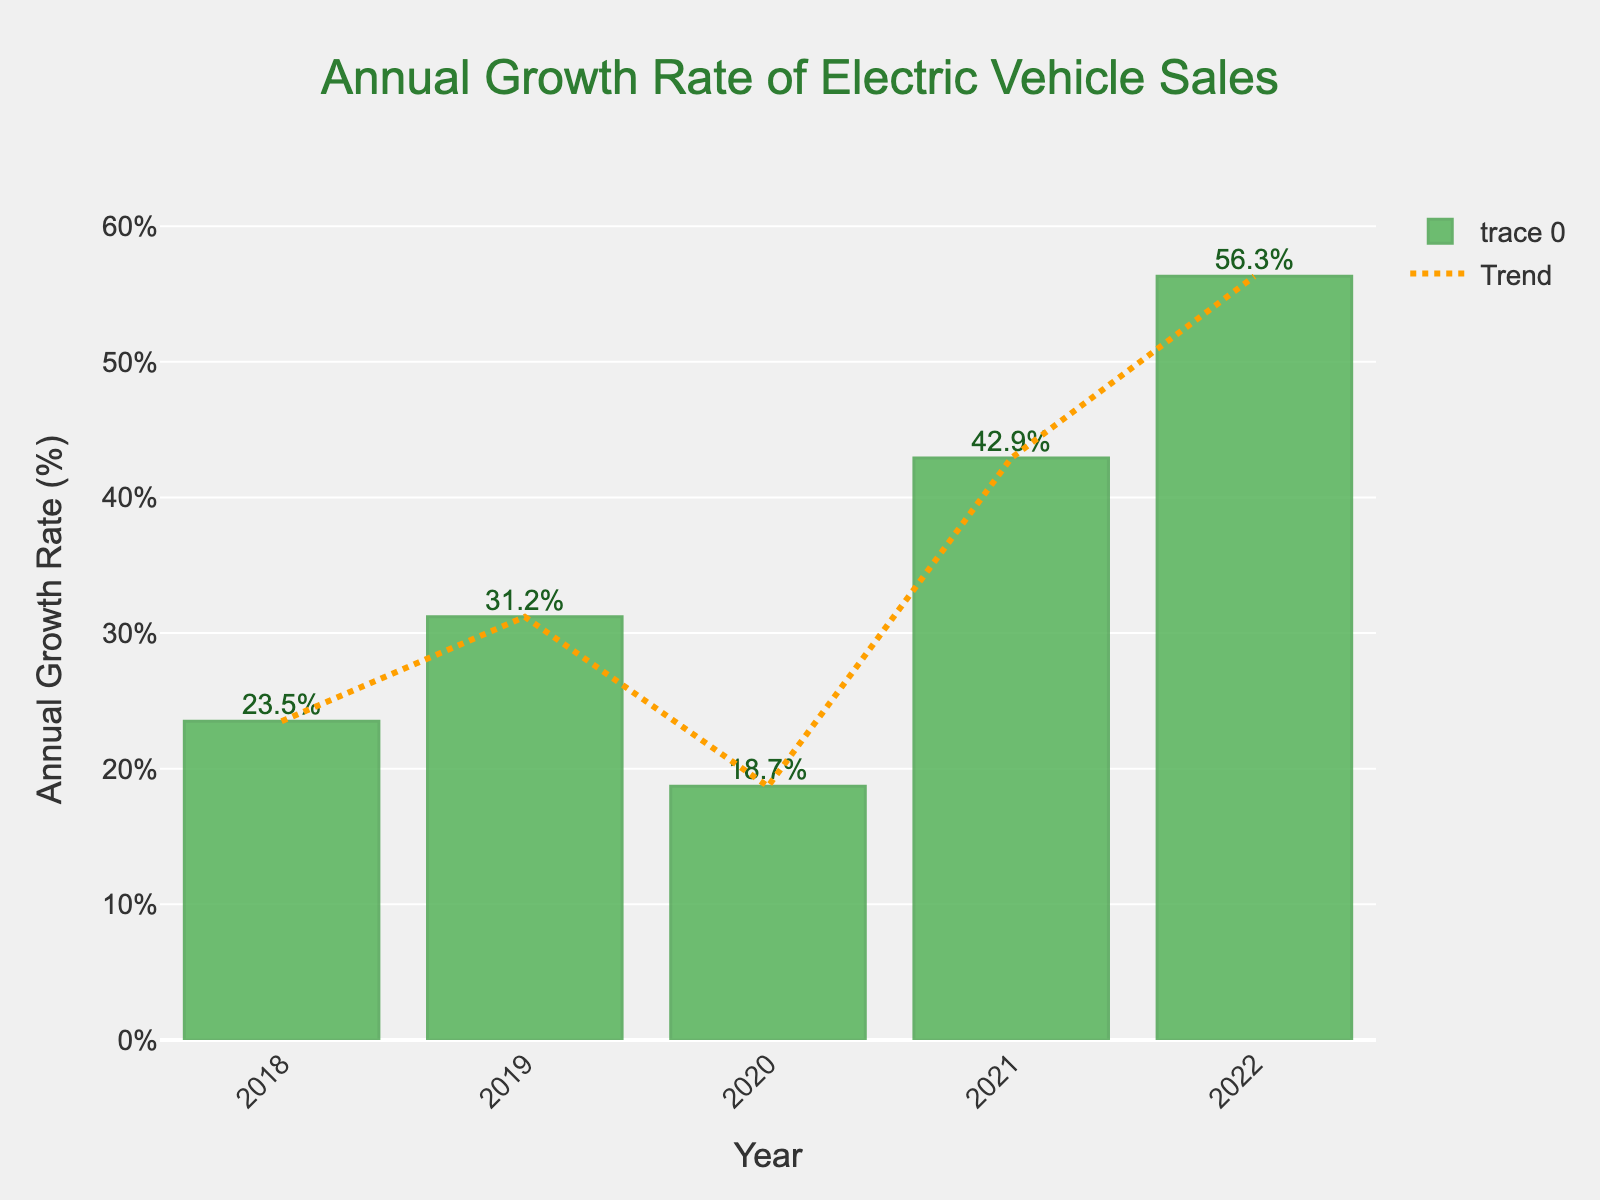What is the highest annual growth rate in electric vehicle sales? Look at the height of the bars and identify the tallest one. The highest bar corresponds to the highest value. The bar for 2022 has the highest value of 56.3%.
Answer: 56.3% Which year had the lowest annual growth rate in electric vehicle sales? Identify the shortest bar on the chart. The shortest bar corresponds to the lowest annual growth rate value. The bar for 2020 has the lowest value of 18.7%.
Answer: 2020 How much did the annual growth rate increase from 2021 to 2022? Subtract the annual growth rate for 2021 from the annual growth rate for 2022. This involves locating the heights of the bars for these years and performing the subtraction: 56.3% (2022) - 42.9% (2021).
Answer: 13.4% What is the average annual growth rate over the 5 years? Add all the annual growth rates and divide by the number of years: (23.5% + 31.2% + 18.7% + 42.9% + 56.3%) / 5.
Answer: 34.52% Which year experienced a higher growth rate: 2018 or 2019? Compare the heights of the bars for 2018 and 2019. The bar for 2019 is taller than that for 2018, indicating a higher growth rate in 2019 with 31.2% compared to 23.5% in 2018.
Answer: 2019 What is the trend in the annual growth rate of electric vehicle sales from 2018 to 2022? Observe the general direction of the bars from left to right. The bars show a general upward trend where the growth rate increases from 23.5% in 2018 to 56.3% in 2022.
Answer: Increasing trend How much higher is the growth rate in 2022 compared to 2018? Subtract the annual growth rate for 2018 from the annual growth rate for 2022: 56.3% (2022) - 23.5% (2018).
Answer: 32.8% Was there any year with a negative growth rate in the given period? Check the y-axis and bars. Negative growth would mean bars extending below the x-axis; however, all bars are above zero, indicating no negative growth years.
Answer: No Comparing the annual growth rates of 2020 and 2021, which has a larger value and by how much? Compare the heights of the bars for 2020 and 2021. The growth rate for 2021 (42.9%) is larger than that for 2020 (18.7%). Calculate the difference: 42.9% - 18.7%.
Answer: 24.2% What is the general color theme of the bars representing the annual growth rate? Observe the color of the bars in the chart. The bars are colored in varying shades of green.
Answer: Green 